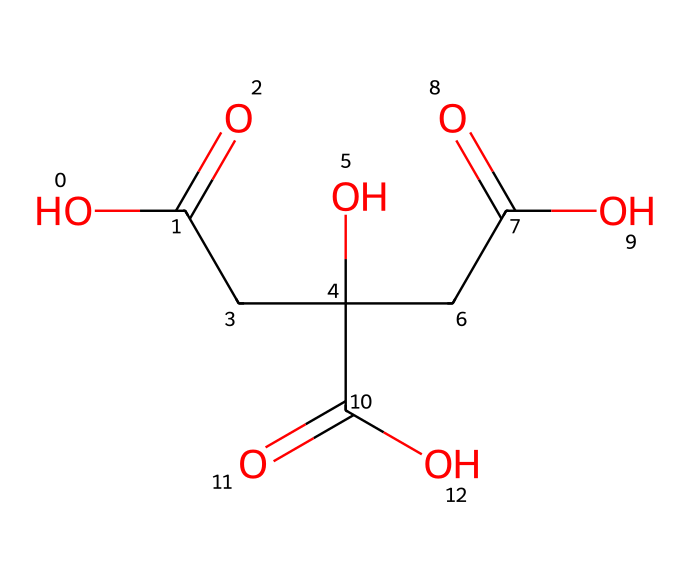What is the total number of carbon atoms in citric acid? By analyzing the SMILES representation, we see that it contains a linear chain of carbon atoms, specifically in the structure, there are six 'C' symbols which represent carbon atoms.
Answer: six How many hydroxyl (–OH) groups does citric acid have? In the SMILES representation, the presence of 'O' atoms followed by 'C' indicates hydroxyl groups. There are three hydroxyl groups present as indicated by 'CC(O)' and 'C(=O)O' which correspond to 'O' atoms associated directly with carbon atoms.
Answer: three What type of functional group is primarily responsible for citric acid's sour taste? Citric acid contains carboxylic acid functional groups (–COOH), indicated by 'C(=O)O' in the structure, which are responsible for the sour taste.
Answer: carboxylic acid How many double bonds does citric acid contain? In the SMILES structure, the 'C(=O)' indicates a double bond between carbon and oxygen. There are three instances of this in the structure, showing that citric acid contains three double bonds.
Answer: three What type of chemical is citric acid classified as? Based on its carboxylic acid functional groups and hydroxyl groups, citric acid is classified as an organic acid, specifically a tricarboxylic acid due to its three carboxylic acid groups.
Answer: organic acid How many oxygen atoms are present in the citric acid structure? In the SMILES representation, counting the number of 'O' symbols gives us the total number of oxygen atoms. There are six 'O' symbols, indicating a total of six oxygen atoms in the molecule.
Answer: six 